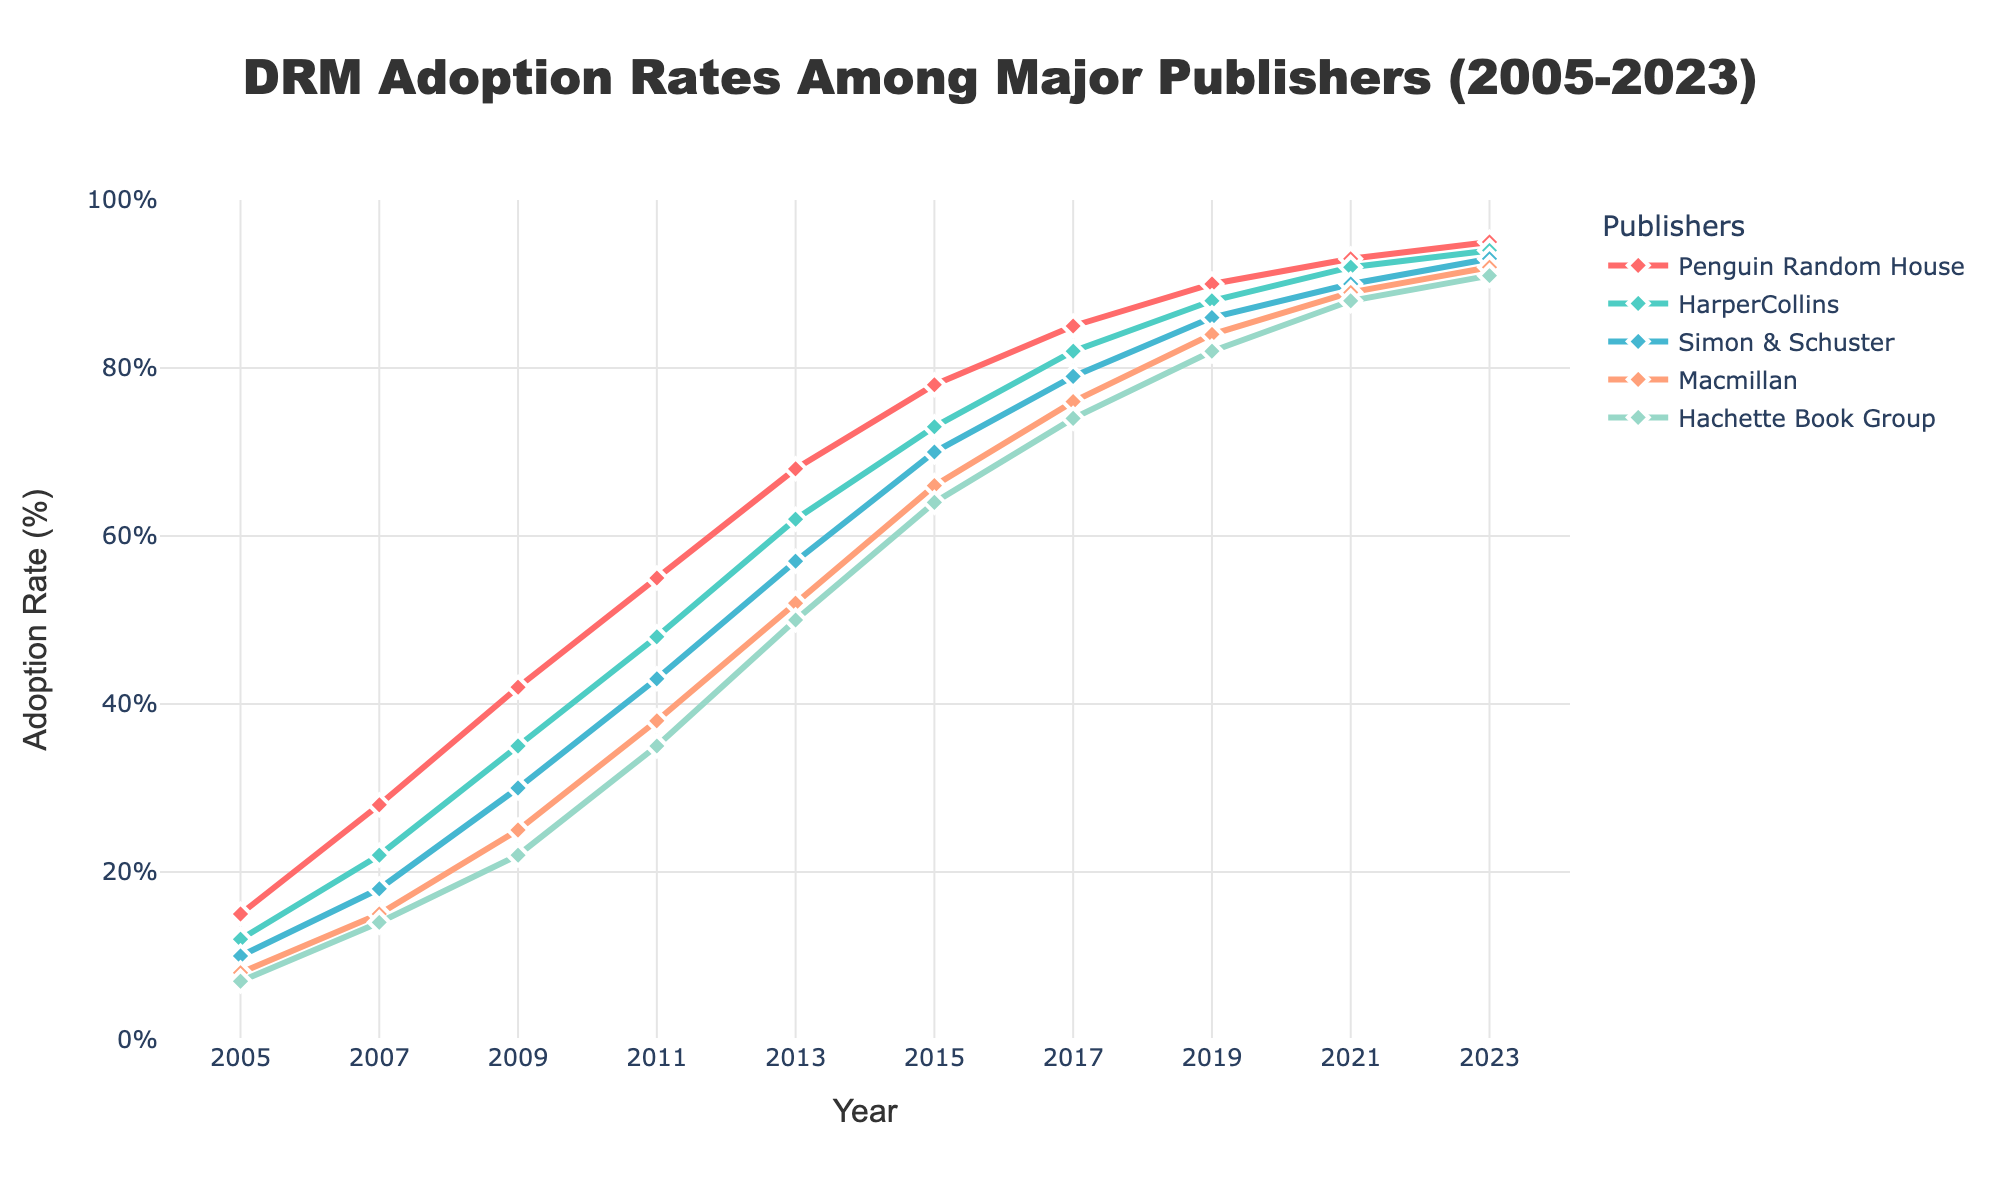What's the overall trend of DRM adoption rates among major publishers from 2005 to 2023? The overall trend shows a steady increase in DRM adoption rates for all major publishers from 2005 to 2023. Each publisher consistently increases their adoption rate over time
Answer: Steady increase How does the DRM adoption rate of Penguin Random House in 2023 compare to 2005? In 2023, Penguin Random House has a DRM adoption rate of 95%, whereas in 2005 it was 15%. The difference in adoption rate is 95% - 15% = 80% increase
Answer: 80% increase Which publisher had the highest DRM adoption rate in 2011? In 2011, the highest DRM adoption rate was recorded by Penguin Random House with an adoption rate of 55%
Answer: Penguin Random House Between 2007 and 2009, which publisher showed the greatest increase in DRM adoption rate and by how much? Between 2007 and 2009, Penguin Random House showed the greatest increase in DRM adoption rate, increasing from 28% to 42%, a difference of 42% - 28% = 14%
Answer: Penguin Random House, 14% How does Simon & Schuster's DRM adoption rate in 2017 compare to Hachette Book Group's adoption rate in 2009? In 2017 Simon & Schuster had an adoption rate of 79%, while Hachette Book Group had a rate of 22% in 2009. The difference is 79% - 22% = 57%
Answer: 57% What's the average DRM adoption rate for Macmillan from 2005 to 2023? To find the average, sum the DRM adoption rates for Macmillan from 2005 to 2023: (8 + 15 + 25 + 38 + 52 + 66 + 76 + 84 + 89 + 92) = 545. Divide this by the number of data points (10): 545 / 10 = 54.5%
Answer: 54.5% Which publisher had the lowest adoption rate in 2005, and what was it? In 2005, the publisher with the lowest DRM adoption rate was Hachette Book Group with a rate of 7%
Answer: Hachette Book Group, 7% What is the difference in DRM adoption rate between HarperCollins and Macmillan in 2023? In 2023, HarperCollins has an adoption rate of 94% and Macmillan has a rate of 92%. The difference is 94% - 92% = 2%
Answer: 2% Comparing the year 2015, how much higher is the adoption rate for Penguin Random House compared to Hachette Book Group? In 2015, Penguin Random House had an adoption rate of 78%, while Hachette Book Group had 64%. The difference is 78% - 64% = 14%
Answer: 14% Which publisher showed the slowest growth in DRM adoption rate from 2011 to 2013? From 2011 to 2013, Hachette Book Group increased from 35% to 50%, a difference of 15%, while all other publishers showed more than 15% increase. Therefore, Hachette Book Group had the slowest growth
Answer: Hachette Book Group 